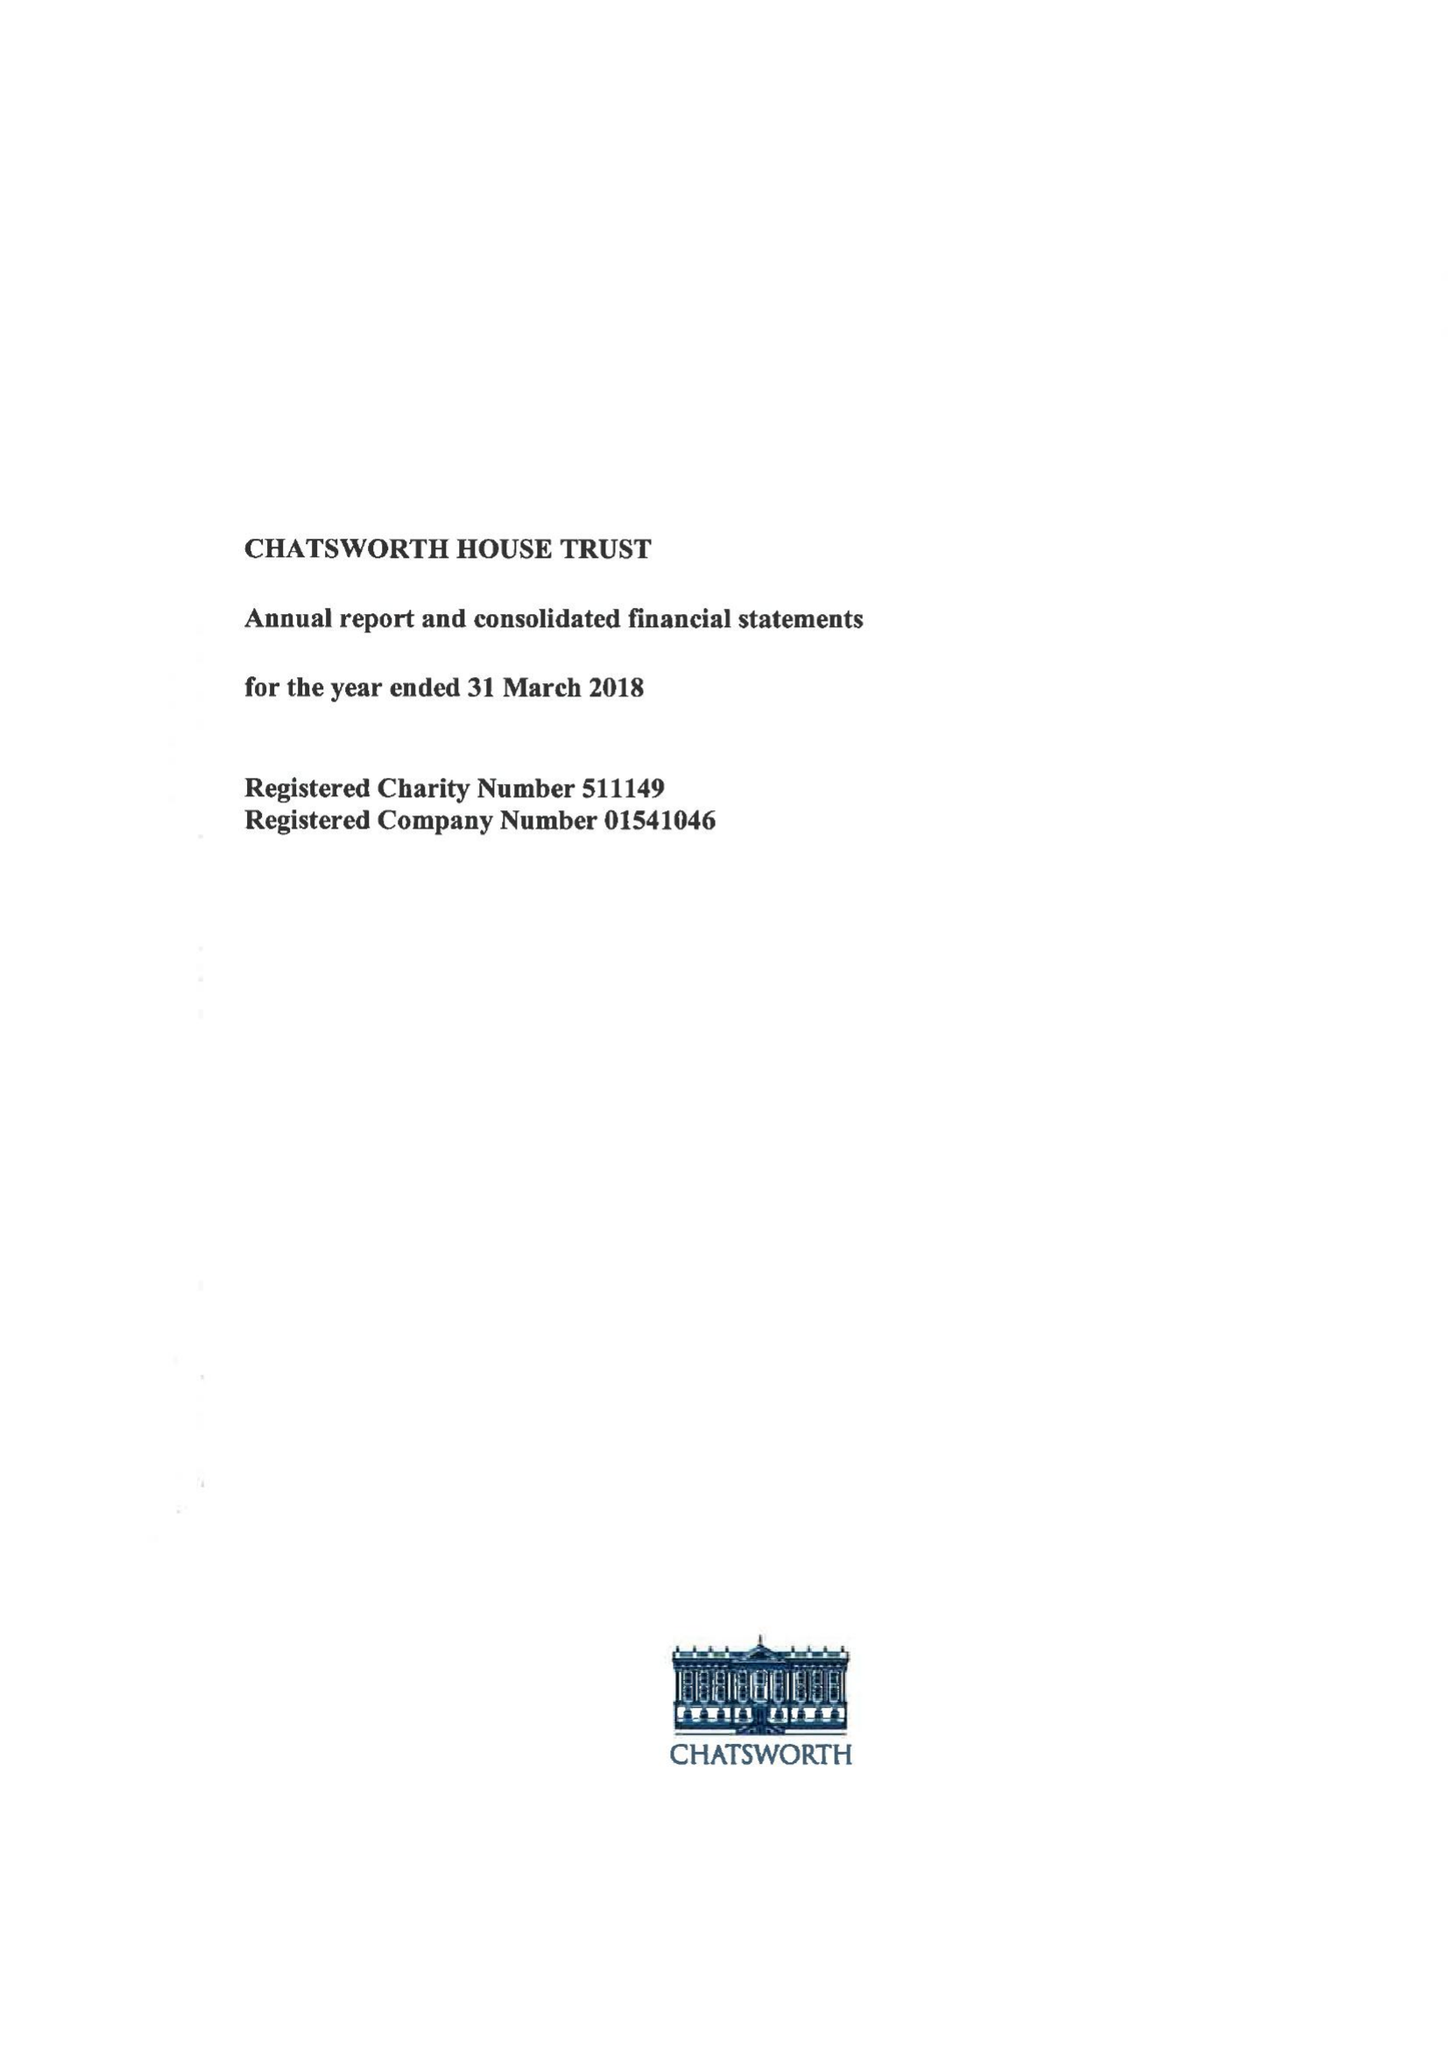What is the value for the address__street_line?
Answer the question using a single word or phrase. None 